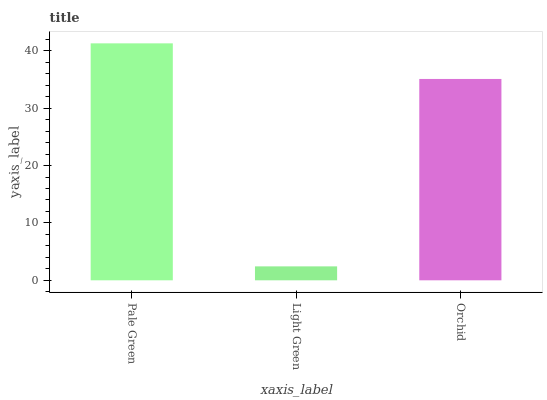Is Orchid the minimum?
Answer yes or no. No. Is Orchid the maximum?
Answer yes or no. No. Is Orchid greater than Light Green?
Answer yes or no. Yes. Is Light Green less than Orchid?
Answer yes or no. Yes. Is Light Green greater than Orchid?
Answer yes or no. No. Is Orchid less than Light Green?
Answer yes or no. No. Is Orchid the high median?
Answer yes or no. Yes. Is Orchid the low median?
Answer yes or no. Yes. Is Pale Green the high median?
Answer yes or no. No. Is Pale Green the low median?
Answer yes or no. No. 